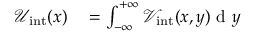<formula> <loc_0><loc_0><loc_500><loc_500>\begin{array} { r l } { \mathcal { U } _ { i n t } ( x ) } & = \int _ { - \infty } ^ { + \infty } \mathcal { V } _ { i n t } ( x , y ) d y } \end{array}</formula> 